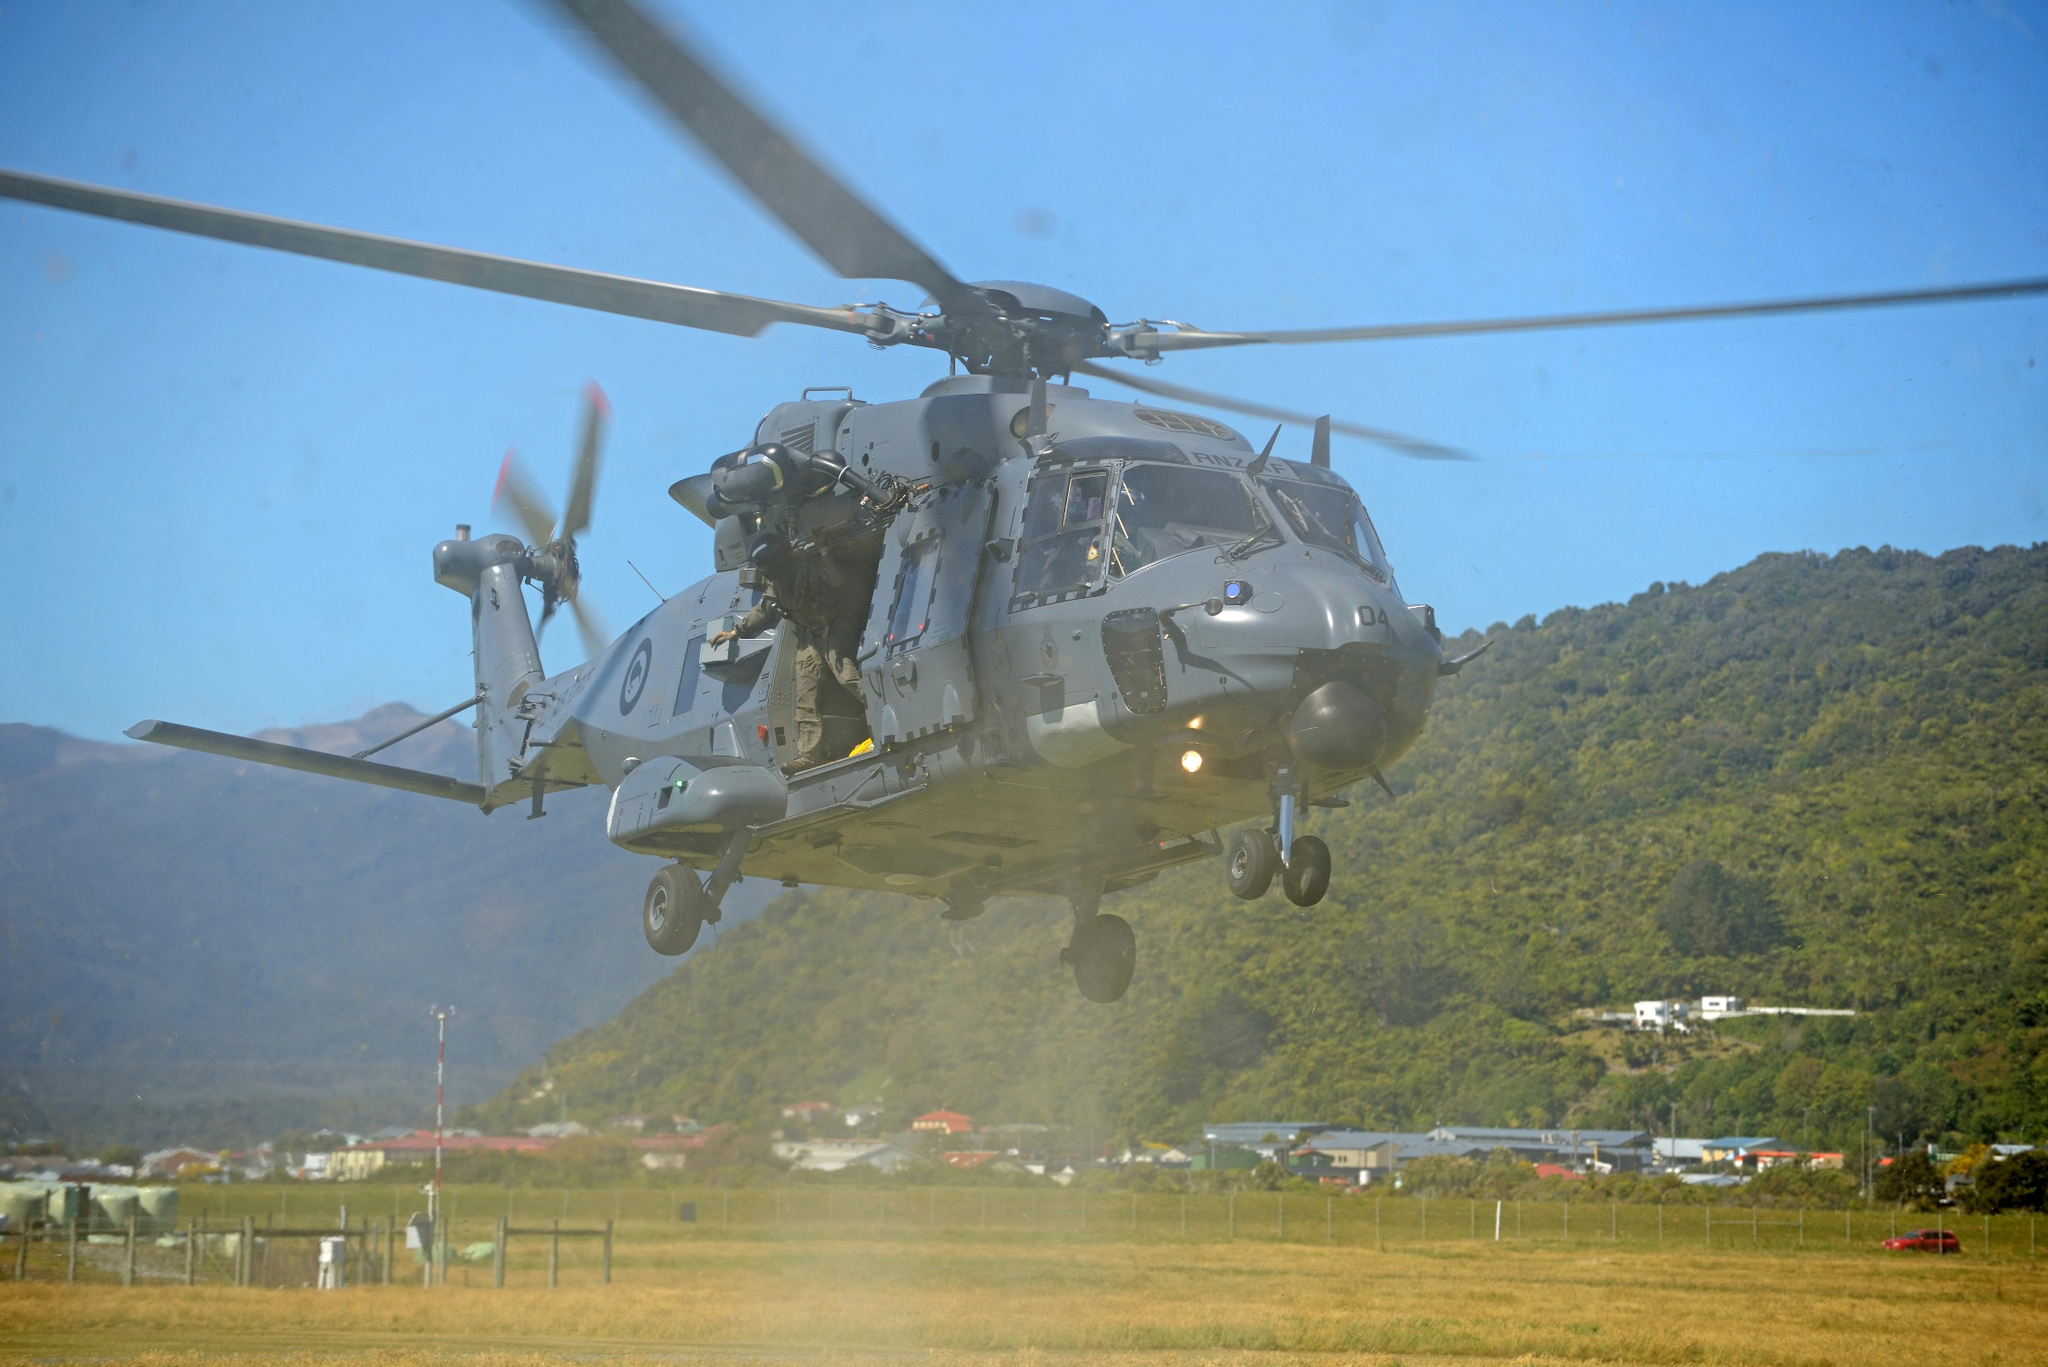Describe the following image. The image presents a striking snapshot of a military helicopter in mid-flight, depicted with stunning clarity. The helicopter, painted in a functional gray, features red and white stripes on its tail, signifying its affiliation. The rotors are captured in motion, imbuing the scene with a dynamic sense of movement.

The helicopter is photographed from a low angle, making it appear powerful and imposing against the backdrop of a bright blue sky. This perspective highlights the helicopter's impressive size and air dominance.

Beneath the helicopter, a lush green field stretches out, contrasting the mechanical nature of the helicopter with the tranquility of nature. The field appears unspoiled, adding an element of peace to the composition.

In the background, distant mountains rise majestically against the horizon, their peaks seamlessly merging with the sky. This adds depth and scale to the image, underscoring the vastness of the landscape.

Overall, the image skillfully juxtaposes human technological prowess and natural serenity, creating a captivating narrative. The distinct elements of the helicopter, field, and mountains collectively tell a compelling story. However, there isn't enough information in the image to precisely identify the specific landmark 'sa_14836.' 